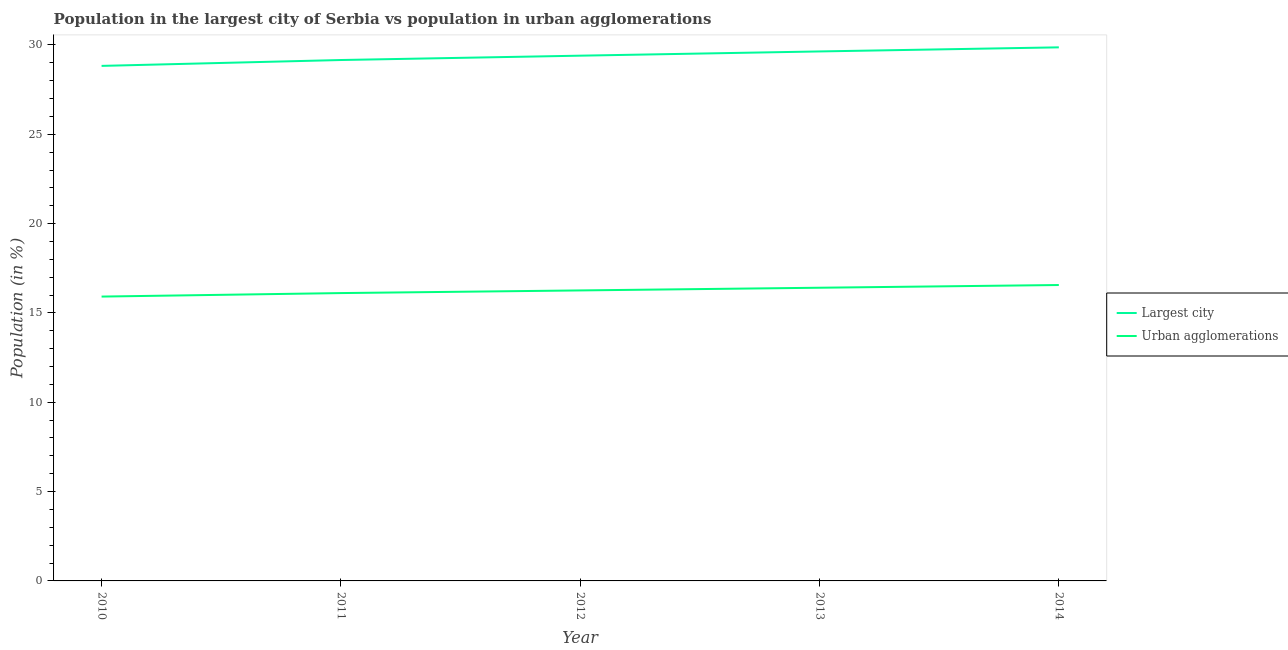Does the line corresponding to population in urban agglomerations intersect with the line corresponding to population in the largest city?
Keep it short and to the point. No. What is the population in urban agglomerations in 2014?
Offer a very short reply. 16.56. Across all years, what is the maximum population in urban agglomerations?
Provide a succinct answer. 16.56. Across all years, what is the minimum population in urban agglomerations?
Offer a terse response. 15.92. In which year was the population in urban agglomerations maximum?
Ensure brevity in your answer.  2014. What is the total population in urban agglomerations in the graph?
Your answer should be very brief. 81.26. What is the difference between the population in the largest city in 2010 and that in 2012?
Offer a terse response. -0.57. What is the difference between the population in the largest city in 2013 and the population in urban agglomerations in 2012?
Your answer should be very brief. 13.38. What is the average population in the largest city per year?
Offer a terse response. 29.38. In the year 2010, what is the difference between the population in the largest city and population in urban agglomerations?
Make the answer very short. 12.91. In how many years, is the population in the largest city greater than 13 %?
Give a very brief answer. 5. What is the ratio of the population in urban agglomerations in 2012 to that in 2013?
Provide a succinct answer. 0.99. Is the population in urban agglomerations in 2012 less than that in 2013?
Make the answer very short. Yes. What is the difference between the highest and the second highest population in urban agglomerations?
Ensure brevity in your answer.  0.15. What is the difference between the highest and the lowest population in the largest city?
Your answer should be compact. 1.04. In how many years, is the population in the largest city greater than the average population in the largest city taken over all years?
Provide a succinct answer. 3. Is the sum of the population in urban agglomerations in 2010 and 2013 greater than the maximum population in the largest city across all years?
Offer a very short reply. Yes. Does the population in the largest city monotonically increase over the years?
Keep it short and to the point. Yes. Is the population in urban agglomerations strictly greater than the population in the largest city over the years?
Ensure brevity in your answer.  No. Is the population in the largest city strictly less than the population in urban agglomerations over the years?
Offer a terse response. No. How many lines are there?
Offer a very short reply. 2. How many years are there in the graph?
Your answer should be very brief. 5. What is the difference between two consecutive major ticks on the Y-axis?
Your answer should be very brief. 5. Where does the legend appear in the graph?
Offer a terse response. Center right. How many legend labels are there?
Your response must be concise. 2. How are the legend labels stacked?
Give a very brief answer. Vertical. What is the title of the graph?
Your response must be concise. Population in the largest city of Serbia vs population in urban agglomerations. What is the label or title of the X-axis?
Your answer should be very brief. Year. What is the Population (in %) in Largest city in 2010?
Provide a succinct answer. 28.83. What is the Population (in %) of Urban agglomerations in 2010?
Provide a short and direct response. 15.92. What is the Population (in %) of Largest city in 2011?
Your answer should be very brief. 29.16. What is the Population (in %) of Urban agglomerations in 2011?
Keep it short and to the point. 16.11. What is the Population (in %) in Largest city in 2012?
Your response must be concise. 29.4. What is the Population (in %) of Urban agglomerations in 2012?
Ensure brevity in your answer.  16.26. What is the Population (in %) in Largest city in 2013?
Your answer should be very brief. 29.64. What is the Population (in %) in Urban agglomerations in 2013?
Give a very brief answer. 16.41. What is the Population (in %) of Largest city in 2014?
Provide a short and direct response. 29.87. What is the Population (in %) of Urban agglomerations in 2014?
Offer a very short reply. 16.56. Across all years, what is the maximum Population (in %) in Largest city?
Ensure brevity in your answer.  29.87. Across all years, what is the maximum Population (in %) of Urban agglomerations?
Offer a very short reply. 16.56. Across all years, what is the minimum Population (in %) in Largest city?
Keep it short and to the point. 28.83. Across all years, what is the minimum Population (in %) of Urban agglomerations?
Keep it short and to the point. 15.92. What is the total Population (in %) of Largest city in the graph?
Your answer should be very brief. 146.89. What is the total Population (in %) in Urban agglomerations in the graph?
Your answer should be very brief. 81.26. What is the difference between the Population (in %) in Largest city in 2010 and that in 2011?
Provide a short and direct response. -0.33. What is the difference between the Population (in %) in Urban agglomerations in 2010 and that in 2011?
Make the answer very short. -0.2. What is the difference between the Population (in %) of Largest city in 2010 and that in 2012?
Provide a short and direct response. -0.57. What is the difference between the Population (in %) of Urban agglomerations in 2010 and that in 2012?
Ensure brevity in your answer.  -0.34. What is the difference between the Population (in %) in Largest city in 2010 and that in 2013?
Provide a short and direct response. -0.81. What is the difference between the Population (in %) of Urban agglomerations in 2010 and that in 2013?
Give a very brief answer. -0.5. What is the difference between the Population (in %) in Largest city in 2010 and that in 2014?
Ensure brevity in your answer.  -1.04. What is the difference between the Population (in %) in Urban agglomerations in 2010 and that in 2014?
Ensure brevity in your answer.  -0.65. What is the difference between the Population (in %) of Largest city in 2011 and that in 2012?
Provide a succinct answer. -0.24. What is the difference between the Population (in %) of Urban agglomerations in 2011 and that in 2012?
Keep it short and to the point. -0.15. What is the difference between the Population (in %) of Largest city in 2011 and that in 2013?
Ensure brevity in your answer.  -0.48. What is the difference between the Population (in %) of Urban agglomerations in 2011 and that in 2013?
Ensure brevity in your answer.  -0.3. What is the difference between the Population (in %) in Largest city in 2011 and that in 2014?
Provide a short and direct response. -0.71. What is the difference between the Population (in %) of Urban agglomerations in 2011 and that in 2014?
Provide a short and direct response. -0.45. What is the difference between the Population (in %) in Largest city in 2012 and that in 2013?
Your response must be concise. -0.24. What is the difference between the Population (in %) of Urban agglomerations in 2012 and that in 2013?
Your response must be concise. -0.15. What is the difference between the Population (in %) in Largest city in 2012 and that in 2014?
Provide a short and direct response. -0.47. What is the difference between the Population (in %) of Urban agglomerations in 2012 and that in 2014?
Keep it short and to the point. -0.3. What is the difference between the Population (in %) of Largest city in 2013 and that in 2014?
Provide a short and direct response. -0.23. What is the difference between the Population (in %) in Urban agglomerations in 2013 and that in 2014?
Offer a very short reply. -0.15. What is the difference between the Population (in %) in Largest city in 2010 and the Population (in %) in Urban agglomerations in 2011?
Your answer should be very brief. 12.72. What is the difference between the Population (in %) of Largest city in 2010 and the Population (in %) of Urban agglomerations in 2012?
Provide a short and direct response. 12.57. What is the difference between the Population (in %) of Largest city in 2010 and the Population (in %) of Urban agglomerations in 2013?
Give a very brief answer. 12.42. What is the difference between the Population (in %) in Largest city in 2010 and the Population (in %) in Urban agglomerations in 2014?
Offer a terse response. 12.27. What is the difference between the Population (in %) in Largest city in 2011 and the Population (in %) in Urban agglomerations in 2012?
Keep it short and to the point. 12.9. What is the difference between the Population (in %) in Largest city in 2011 and the Population (in %) in Urban agglomerations in 2013?
Offer a very short reply. 12.75. What is the difference between the Population (in %) of Largest city in 2011 and the Population (in %) of Urban agglomerations in 2014?
Your answer should be very brief. 12.59. What is the difference between the Population (in %) of Largest city in 2012 and the Population (in %) of Urban agglomerations in 2013?
Ensure brevity in your answer.  12.99. What is the difference between the Population (in %) of Largest city in 2012 and the Population (in %) of Urban agglomerations in 2014?
Give a very brief answer. 12.84. What is the difference between the Population (in %) in Largest city in 2013 and the Population (in %) in Urban agglomerations in 2014?
Offer a terse response. 13.07. What is the average Population (in %) of Largest city per year?
Your answer should be compact. 29.38. What is the average Population (in %) of Urban agglomerations per year?
Your answer should be very brief. 16.25. In the year 2010, what is the difference between the Population (in %) of Largest city and Population (in %) of Urban agglomerations?
Offer a very short reply. 12.91. In the year 2011, what is the difference between the Population (in %) in Largest city and Population (in %) in Urban agglomerations?
Provide a succinct answer. 13.05. In the year 2012, what is the difference between the Population (in %) of Largest city and Population (in %) of Urban agglomerations?
Offer a terse response. 13.14. In the year 2013, what is the difference between the Population (in %) of Largest city and Population (in %) of Urban agglomerations?
Offer a very short reply. 13.23. In the year 2014, what is the difference between the Population (in %) in Largest city and Population (in %) in Urban agglomerations?
Offer a very short reply. 13.3. What is the ratio of the Population (in %) in Largest city in 2010 to that in 2011?
Give a very brief answer. 0.99. What is the ratio of the Population (in %) of Urban agglomerations in 2010 to that in 2011?
Make the answer very short. 0.99. What is the ratio of the Population (in %) of Largest city in 2010 to that in 2012?
Your answer should be compact. 0.98. What is the ratio of the Population (in %) in Urban agglomerations in 2010 to that in 2012?
Make the answer very short. 0.98. What is the ratio of the Population (in %) in Largest city in 2010 to that in 2013?
Your response must be concise. 0.97. What is the ratio of the Population (in %) of Urban agglomerations in 2010 to that in 2013?
Make the answer very short. 0.97. What is the ratio of the Population (in %) of Largest city in 2010 to that in 2014?
Provide a succinct answer. 0.97. What is the ratio of the Population (in %) in Urban agglomerations in 2010 to that in 2014?
Your answer should be very brief. 0.96. What is the ratio of the Population (in %) in Urban agglomerations in 2011 to that in 2012?
Make the answer very short. 0.99. What is the ratio of the Population (in %) of Largest city in 2011 to that in 2013?
Your answer should be compact. 0.98. What is the ratio of the Population (in %) of Urban agglomerations in 2011 to that in 2013?
Ensure brevity in your answer.  0.98. What is the ratio of the Population (in %) in Largest city in 2011 to that in 2014?
Give a very brief answer. 0.98. What is the ratio of the Population (in %) in Urban agglomerations in 2011 to that in 2014?
Your response must be concise. 0.97. What is the ratio of the Population (in %) of Largest city in 2012 to that in 2014?
Keep it short and to the point. 0.98. What is the ratio of the Population (in %) of Urban agglomerations in 2012 to that in 2014?
Offer a very short reply. 0.98. What is the difference between the highest and the second highest Population (in %) in Largest city?
Keep it short and to the point. 0.23. What is the difference between the highest and the second highest Population (in %) of Urban agglomerations?
Your answer should be very brief. 0.15. What is the difference between the highest and the lowest Population (in %) of Largest city?
Provide a short and direct response. 1.04. What is the difference between the highest and the lowest Population (in %) of Urban agglomerations?
Provide a short and direct response. 0.65. 